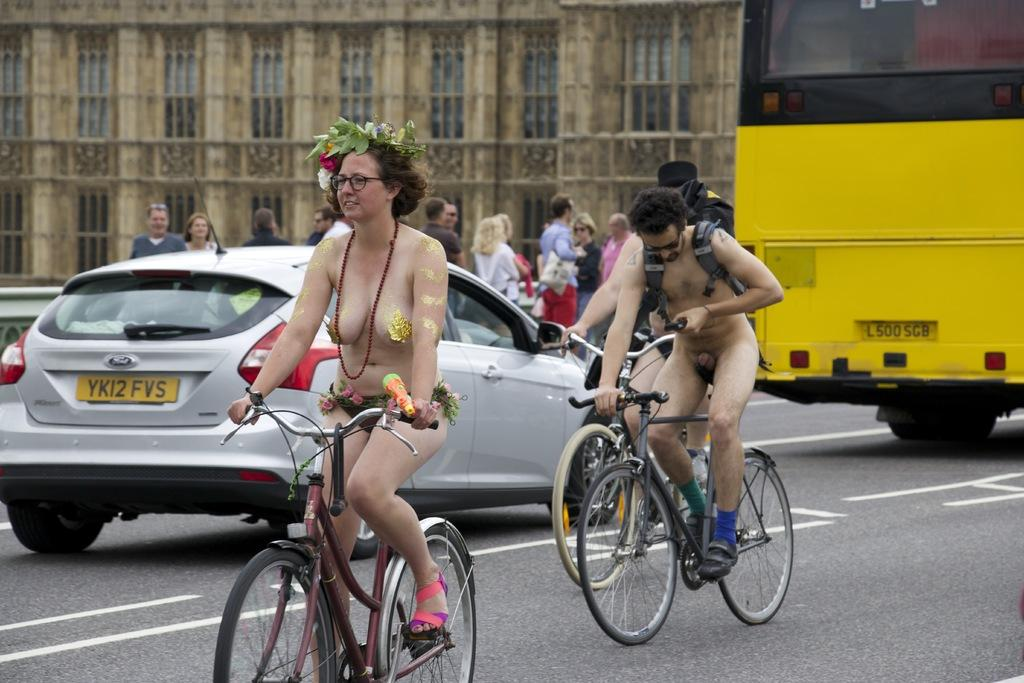What are the people in the image doing? The people in the image are riding bicycles. What are the people wearing while riding bicycles? The people are nude in the image. Can you see the goose that the friend brought to the event in the image? There is no goose or friend present in the image, and no event is mentioned. 